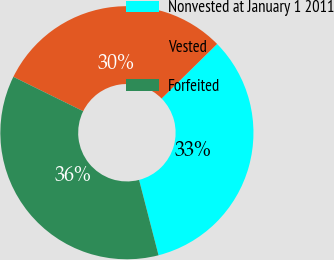<chart> <loc_0><loc_0><loc_500><loc_500><pie_chart><fcel>Nonvested at January 1 2011<fcel>Vested<fcel>Forfeited<nl><fcel>33.35%<fcel>30.35%<fcel>36.3%<nl></chart> 